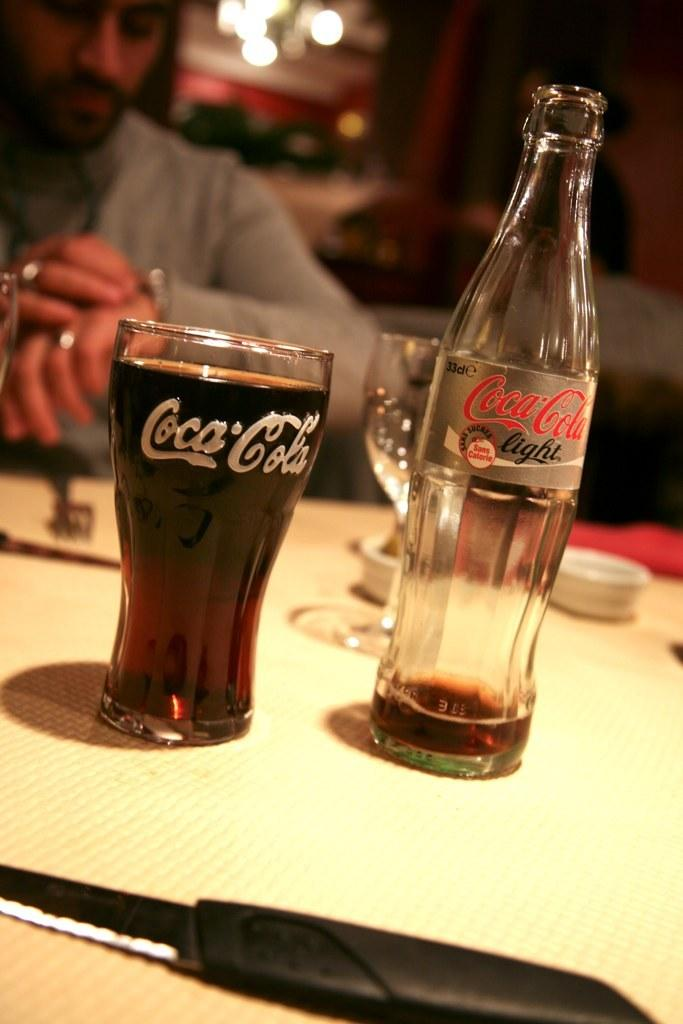Provide a one-sentence caption for the provided image. An empty bottle of Coca-Cola sits to the right of a full glass of Coca-Cola. 